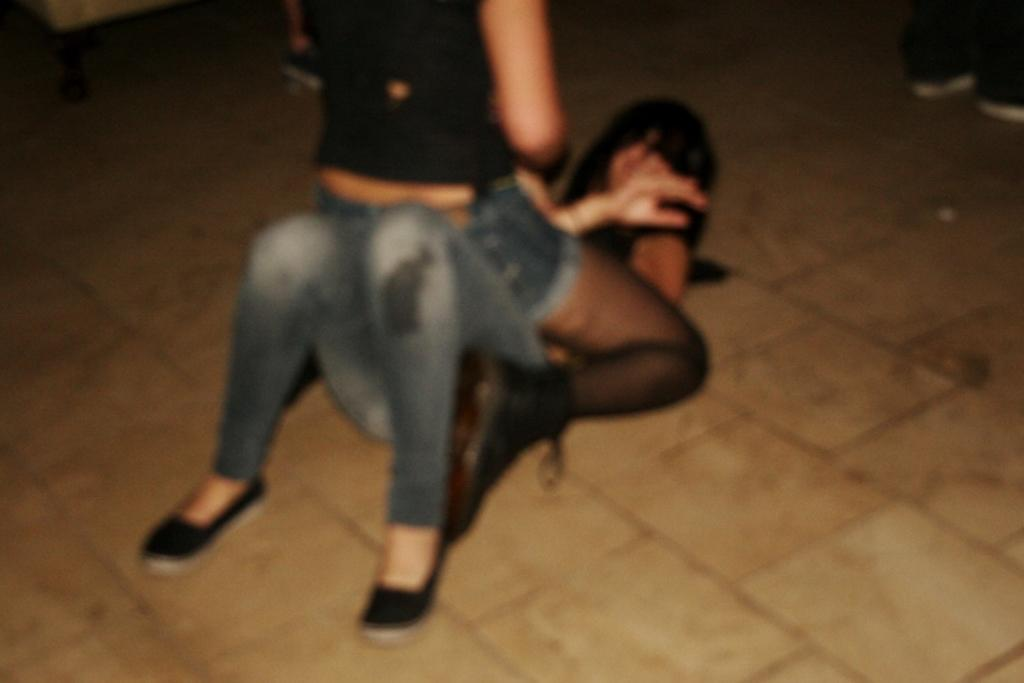What is happening between the two people in the image? There is a person sitting on another person in the image. Can you describe the legs of the two persons in the background of the image? The legs of the two persons in the background are visible. What type of fan is being used by the person sitting on the sofa in the image? There is no fan or sofa present in the image; it only shows two people with one person sitting on the other. 